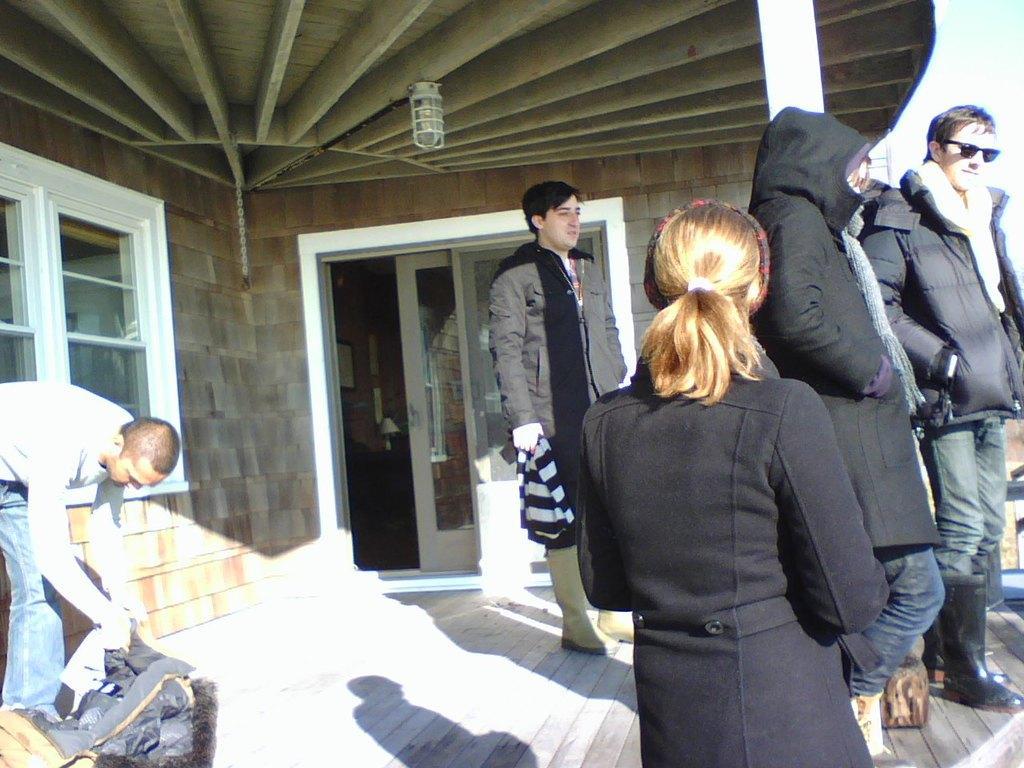Describe this image in one or two sentences. In this picture I can see there are few people standing here and there is a woman and a girl standing here wearing a black colored coats and there are few other men standing and there is a building with a door, a window and a light attached to the roof. 